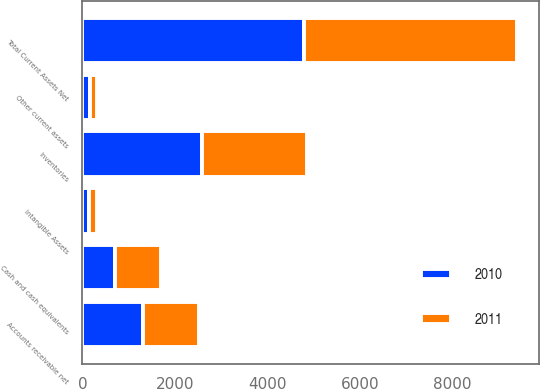Convert chart to OTSL. <chart><loc_0><loc_0><loc_500><loc_500><stacked_bar_chart><ecel><fcel>Cash and cash equivalents<fcel>Accounts receivable net<fcel>Inventories<fcel>Other current assets<fcel>Total Current Assets Net<fcel>Intangible Assets<nl><fcel>2010<fcel>716<fcel>1321<fcel>2587<fcel>156<fcel>4780<fcel>149<nl><fcel>2011<fcel>978<fcel>1198<fcel>2274<fcel>168<fcel>4618<fcel>166<nl></chart> 